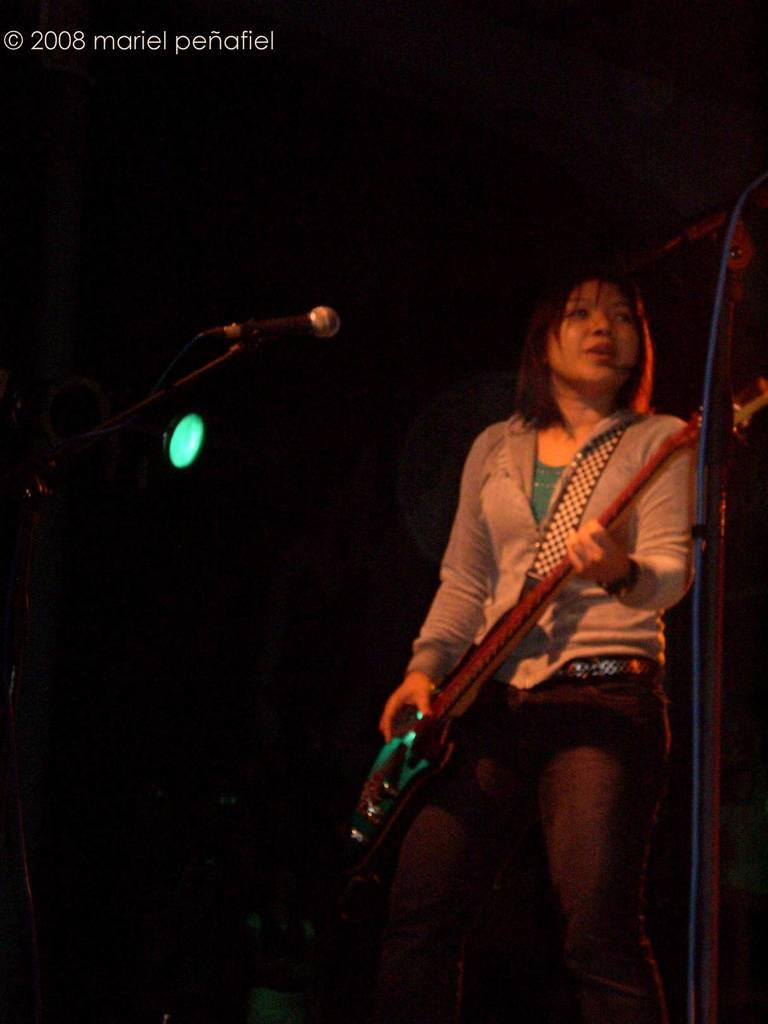Who is the main subject in the image? There is a woman in the image. What is the woman wearing? The woman is wearing a green t-shirt and a pink jacket. What is the woman doing in the image? The woman is playing a guitar. What object is in front of the woman? There is a microphone in front of the woman. What can be seen in the background of the image? There is a light in the background of the image. What type of battle is taking place in the image? There is no battle present in the image; it features a woman playing a guitar. What kind of mist can be seen in the image? There is no mist present in the image. 